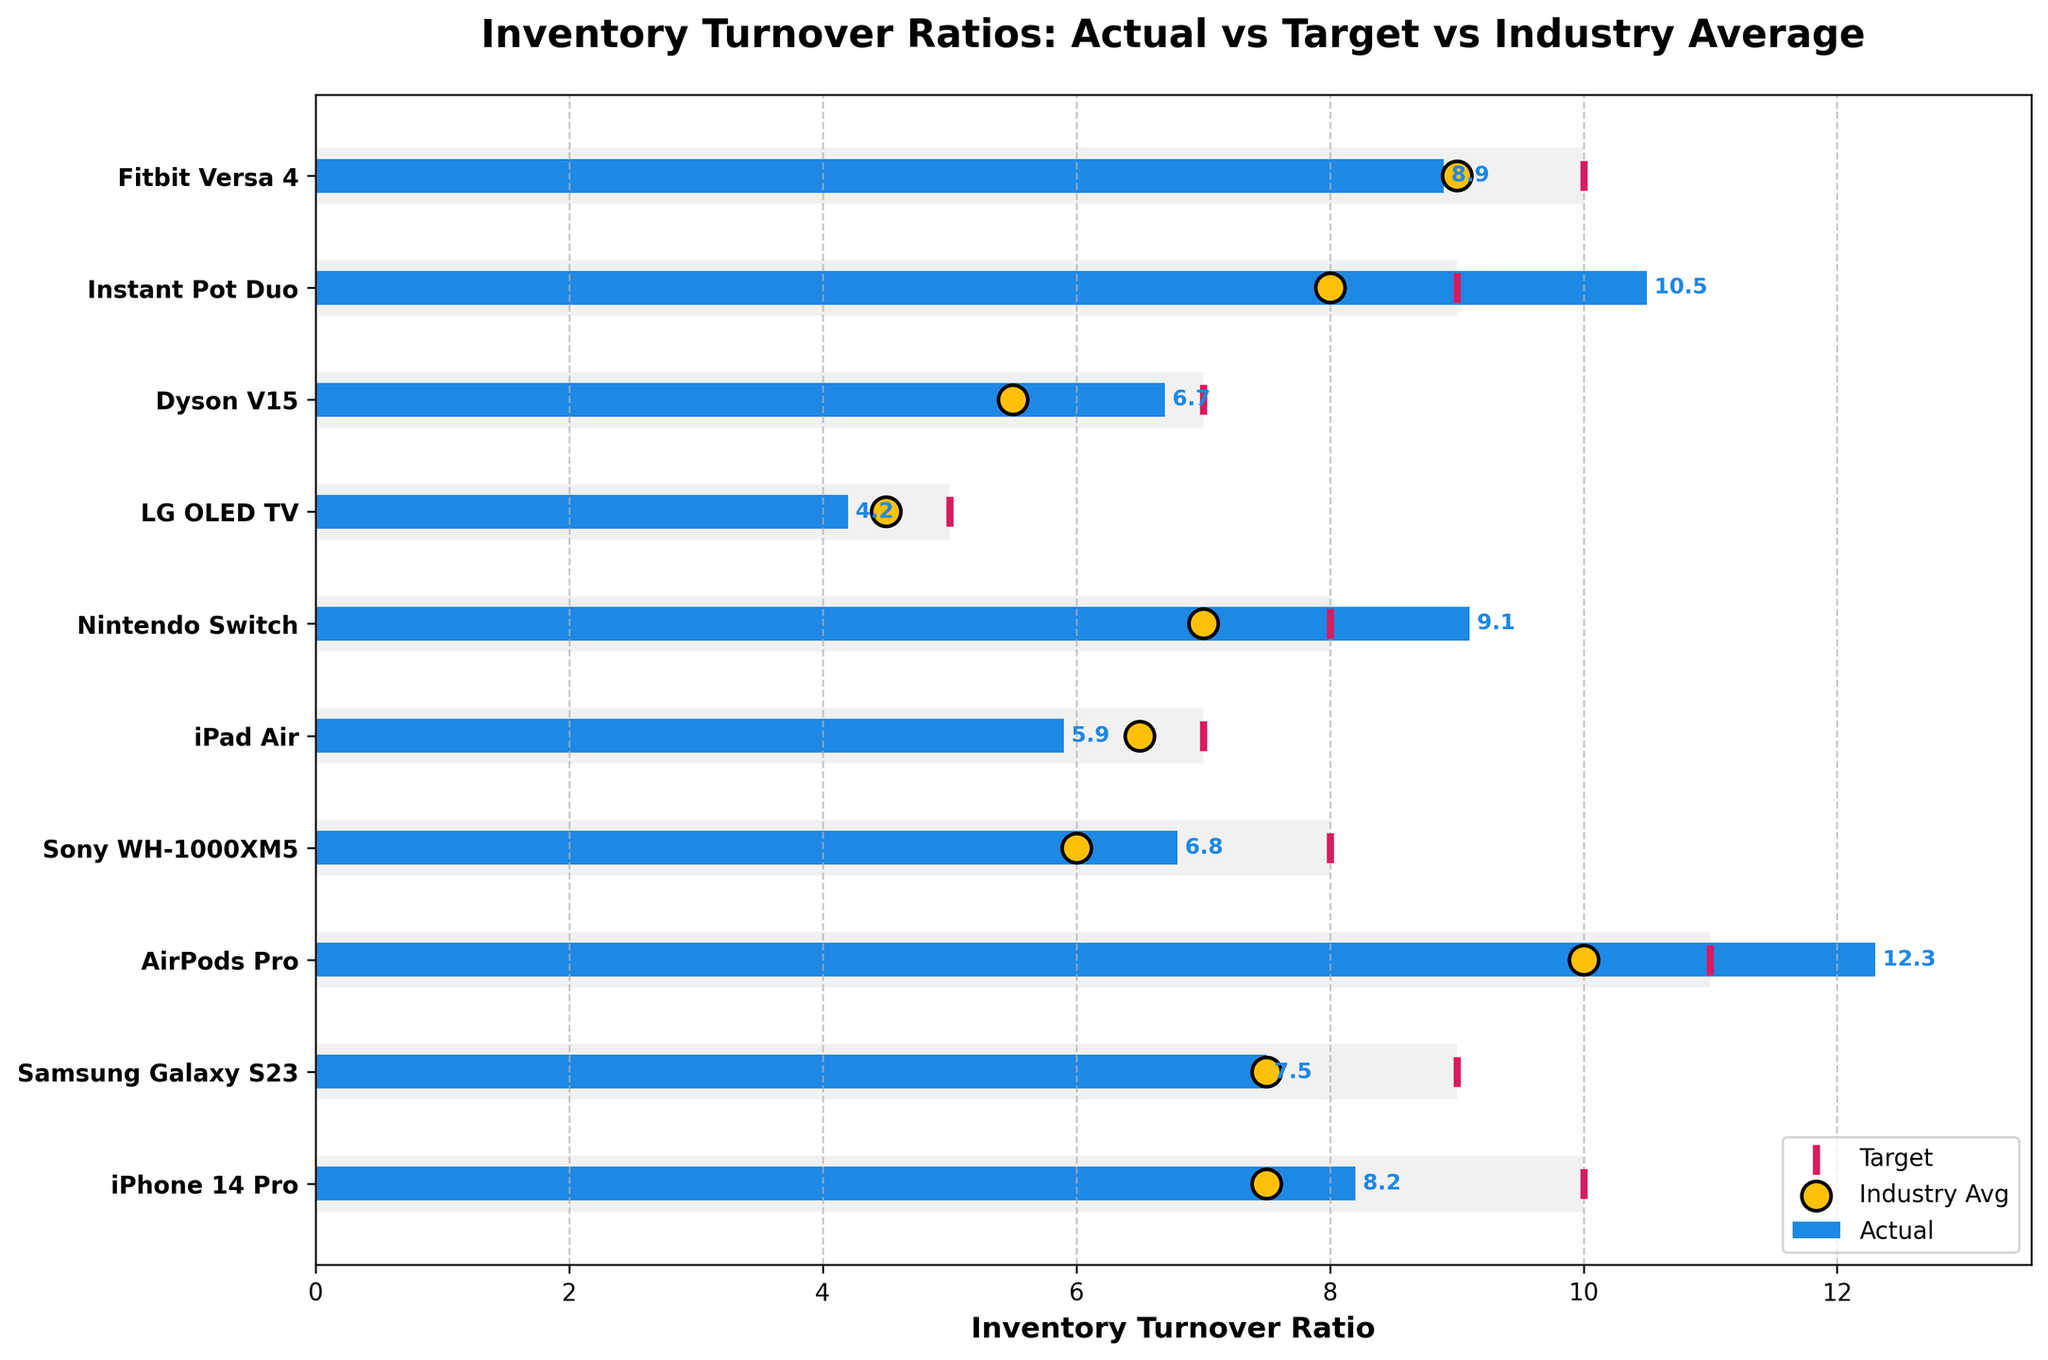What's the title of the figure? The title is displayed at the top of the figure. It reads 'Inventory Turnover Ratios: Actual vs Target vs Industry Average'.
Answer: Inventory Turnover Ratios: Actual vs Target vs Industry Average Which item has the highest actual turnover ratio? The bar for 'AirPods Pro' extends the farthest to the right on the actual turnover scale.
Answer: AirPods Pro Which item has the lowest actual turnover ratio and what is its value? Look for the shortest actual turnover bar on the figure. LG OLED TV has the smallest bar, its length indicates its value when checked against the axis.
Answer: LG OLED TV, 4.2 What is the difference between the actual turnover ratios of iPhone 14 Pro and Samsung Galaxy S23? Subtract the actual turnover ratio of Samsung Galaxy S23 (7.5) from that of iPhone 14 Pro (8.2).
Answer: 0.7 How many items have an actual turnover ratio higher than the industry average? Count all items where the blue bar extends further right than the yellow 'o' marker.
Answer: 6 items Which item most closely matches its target turnover ratio? Determine the item whose actual turnover bar reaches closest to its magenta target line.
Answer: Dyson V15 